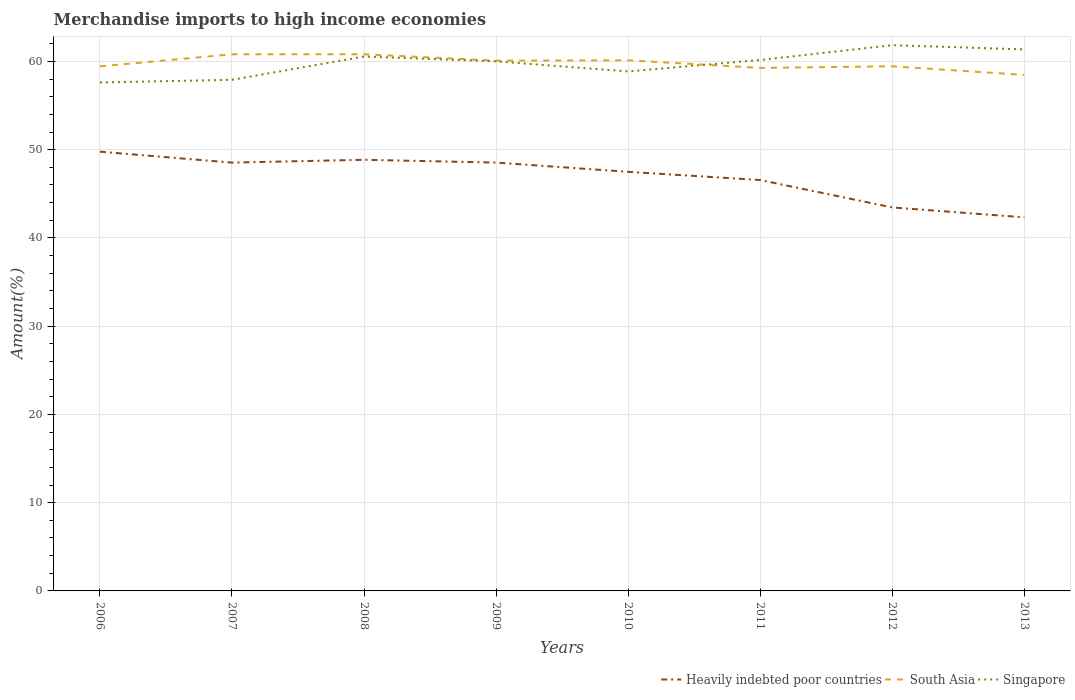Is the number of lines equal to the number of legend labels?
Your response must be concise. Yes. Across all years, what is the maximum percentage of amount earned from merchandise imports in Heavily indebted poor countries?
Your answer should be very brief. 42.33. What is the total percentage of amount earned from merchandise imports in Heavily indebted poor countries in the graph?
Give a very brief answer. -0.32. What is the difference between the highest and the second highest percentage of amount earned from merchandise imports in Heavily indebted poor countries?
Provide a succinct answer. 7.44. What is the difference between the highest and the lowest percentage of amount earned from merchandise imports in Singapore?
Offer a very short reply. 5. How many lines are there?
Your response must be concise. 3. What is the difference between two consecutive major ticks on the Y-axis?
Your response must be concise. 10. Does the graph contain any zero values?
Ensure brevity in your answer.  No. Does the graph contain grids?
Give a very brief answer. Yes. Where does the legend appear in the graph?
Provide a succinct answer. Bottom right. What is the title of the graph?
Offer a terse response. Merchandise imports to high income economies. What is the label or title of the Y-axis?
Provide a succinct answer. Amount(%). What is the Amount(%) of Heavily indebted poor countries in 2006?
Offer a terse response. 49.77. What is the Amount(%) of South Asia in 2006?
Make the answer very short. 59.44. What is the Amount(%) of Singapore in 2006?
Your response must be concise. 57.61. What is the Amount(%) of Heavily indebted poor countries in 2007?
Provide a short and direct response. 48.53. What is the Amount(%) of South Asia in 2007?
Offer a terse response. 60.81. What is the Amount(%) in Singapore in 2007?
Make the answer very short. 57.92. What is the Amount(%) in Heavily indebted poor countries in 2008?
Ensure brevity in your answer.  48.85. What is the Amount(%) in South Asia in 2008?
Offer a terse response. 60.81. What is the Amount(%) in Singapore in 2008?
Your answer should be compact. 60.55. What is the Amount(%) of Heavily indebted poor countries in 2009?
Offer a very short reply. 48.54. What is the Amount(%) of South Asia in 2009?
Make the answer very short. 60.08. What is the Amount(%) in Singapore in 2009?
Ensure brevity in your answer.  60. What is the Amount(%) of Heavily indebted poor countries in 2010?
Keep it short and to the point. 47.49. What is the Amount(%) in South Asia in 2010?
Offer a terse response. 60.13. What is the Amount(%) in Singapore in 2010?
Ensure brevity in your answer.  58.87. What is the Amount(%) of Heavily indebted poor countries in 2011?
Your response must be concise. 46.56. What is the Amount(%) of South Asia in 2011?
Give a very brief answer. 59.26. What is the Amount(%) in Singapore in 2011?
Your answer should be compact. 60.16. What is the Amount(%) of Heavily indebted poor countries in 2012?
Give a very brief answer. 43.45. What is the Amount(%) of South Asia in 2012?
Your answer should be very brief. 59.45. What is the Amount(%) in Singapore in 2012?
Give a very brief answer. 61.84. What is the Amount(%) in Heavily indebted poor countries in 2013?
Offer a very short reply. 42.33. What is the Amount(%) in South Asia in 2013?
Provide a succinct answer. 58.47. What is the Amount(%) of Singapore in 2013?
Keep it short and to the point. 61.36. Across all years, what is the maximum Amount(%) of Heavily indebted poor countries?
Your answer should be very brief. 49.77. Across all years, what is the maximum Amount(%) of South Asia?
Offer a very short reply. 60.81. Across all years, what is the maximum Amount(%) in Singapore?
Your answer should be compact. 61.84. Across all years, what is the minimum Amount(%) in Heavily indebted poor countries?
Provide a succinct answer. 42.33. Across all years, what is the minimum Amount(%) of South Asia?
Ensure brevity in your answer.  58.47. Across all years, what is the minimum Amount(%) in Singapore?
Offer a very short reply. 57.61. What is the total Amount(%) in Heavily indebted poor countries in the graph?
Your answer should be very brief. 375.53. What is the total Amount(%) in South Asia in the graph?
Your answer should be compact. 478.44. What is the total Amount(%) in Singapore in the graph?
Offer a very short reply. 478.32. What is the difference between the Amount(%) in Heavily indebted poor countries in 2006 and that in 2007?
Your answer should be very brief. 1.24. What is the difference between the Amount(%) in South Asia in 2006 and that in 2007?
Give a very brief answer. -1.37. What is the difference between the Amount(%) in Singapore in 2006 and that in 2007?
Give a very brief answer. -0.3. What is the difference between the Amount(%) of Heavily indebted poor countries in 2006 and that in 2008?
Your answer should be very brief. 0.92. What is the difference between the Amount(%) of South Asia in 2006 and that in 2008?
Make the answer very short. -1.37. What is the difference between the Amount(%) of Singapore in 2006 and that in 2008?
Keep it short and to the point. -2.94. What is the difference between the Amount(%) in Heavily indebted poor countries in 2006 and that in 2009?
Keep it short and to the point. 1.24. What is the difference between the Amount(%) in South Asia in 2006 and that in 2009?
Provide a succinct answer. -0.64. What is the difference between the Amount(%) of Singapore in 2006 and that in 2009?
Your answer should be compact. -2.39. What is the difference between the Amount(%) in Heavily indebted poor countries in 2006 and that in 2010?
Keep it short and to the point. 2.28. What is the difference between the Amount(%) of South Asia in 2006 and that in 2010?
Provide a short and direct response. -0.69. What is the difference between the Amount(%) in Singapore in 2006 and that in 2010?
Your answer should be compact. -1.25. What is the difference between the Amount(%) of Heavily indebted poor countries in 2006 and that in 2011?
Give a very brief answer. 3.21. What is the difference between the Amount(%) in South Asia in 2006 and that in 2011?
Your answer should be very brief. 0.18. What is the difference between the Amount(%) in Singapore in 2006 and that in 2011?
Provide a short and direct response. -2.55. What is the difference between the Amount(%) in Heavily indebted poor countries in 2006 and that in 2012?
Your answer should be compact. 6.32. What is the difference between the Amount(%) in South Asia in 2006 and that in 2012?
Provide a short and direct response. -0.01. What is the difference between the Amount(%) of Singapore in 2006 and that in 2012?
Your response must be concise. -4.23. What is the difference between the Amount(%) in Heavily indebted poor countries in 2006 and that in 2013?
Make the answer very short. 7.44. What is the difference between the Amount(%) in South Asia in 2006 and that in 2013?
Give a very brief answer. 0.97. What is the difference between the Amount(%) in Singapore in 2006 and that in 2013?
Offer a very short reply. -3.75. What is the difference between the Amount(%) of Heavily indebted poor countries in 2007 and that in 2008?
Ensure brevity in your answer.  -0.32. What is the difference between the Amount(%) in South Asia in 2007 and that in 2008?
Offer a terse response. -0. What is the difference between the Amount(%) of Singapore in 2007 and that in 2008?
Offer a very short reply. -2.64. What is the difference between the Amount(%) in Heavily indebted poor countries in 2007 and that in 2009?
Provide a short and direct response. -0. What is the difference between the Amount(%) of South Asia in 2007 and that in 2009?
Your answer should be very brief. 0.72. What is the difference between the Amount(%) of Singapore in 2007 and that in 2009?
Ensure brevity in your answer.  -2.09. What is the difference between the Amount(%) of Heavily indebted poor countries in 2007 and that in 2010?
Keep it short and to the point. 1.04. What is the difference between the Amount(%) of South Asia in 2007 and that in 2010?
Make the answer very short. 0.68. What is the difference between the Amount(%) in Singapore in 2007 and that in 2010?
Your response must be concise. -0.95. What is the difference between the Amount(%) of Heavily indebted poor countries in 2007 and that in 2011?
Keep it short and to the point. 1.98. What is the difference between the Amount(%) in South Asia in 2007 and that in 2011?
Your answer should be compact. 1.55. What is the difference between the Amount(%) in Singapore in 2007 and that in 2011?
Your response must be concise. -2.25. What is the difference between the Amount(%) in Heavily indebted poor countries in 2007 and that in 2012?
Provide a short and direct response. 5.08. What is the difference between the Amount(%) of South Asia in 2007 and that in 2012?
Your answer should be compact. 1.36. What is the difference between the Amount(%) in Singapore in 2007 and that in 2012?
Your answer should be very brief. -3.92. What is the difference between the Amount(%) in Heavily indebted poor countries in 2007 and that in 2013?
Provide a short and direct response. 6.2. What is the difference between the Amount(%) in South Asia in 2007 and that in 2013?
Offer a very short reply. 2.34. What is the difference between the Amount(%) in Singapore in 2007 and that in 2013?
Provide a short and direct response. -3.44. What is the difference between the Amount(%) of Heavily indebted poor countries in 2008 and that in 2009?
Provide a succinct answer. 0.32. What is the difference between the Amount(%) of South Asia in 2008 and that in 2009?
Provide a succinct answer. 0.73. What is the difference between the Amount(%) in Singapore in 2008 and that in 2009?
Give a very brief answer. 0.55. What is the difference between the Amount(%) of Heavily indebted poor countries in 2008 and that in 2010?
Your answer should be compact. 1.36. What is the difference between the Amount(%) in South Asia in 2008 and that in 2010?
Offer a terse response. 0.68. What is the difference between the Amount(%) of Singapore in 2008 and that in 2010?
Keep it short and to the point. 1.69. What is the difference between the Amount(%) in Heavily indebted poor countries in 2008 and that in 2011?
Ensure brevity in your answer.  2.3. What is the difference between the Amount(%) of South Asia in 2008 and that in 2011?
Offer a terse response. 1.55. What is the difference between the Amount(%) in Singapore in 2008 and that in 2011?
Give a very brief answer. 0.39. What is the difference between the Amount(%) in Heavily indebted poor countries in 2008 and that in 2012?
Make the answer very short. 5.4. What is the difference between the Amount(%) of South Asia in 2008 and that in 2012?
Provide a short and direct response. 1.36. What is the difference between the Amount(%) of Singapore in 2008 and that in 2012?
Give a very brief answer. -1.29. What is the difference between the Amount(%) in Heavily indebted poor countries in 2008 and that in 2013?
Provide a succinct answer. 6.52. What is the difference between the Amount(%) in South Asia in 2008 and that in 2013?
Keep it short and to the point. 2.34. What is the difference between the Amount(%) of Singapore in 2008 and that in 2013?
Make the answer very short. -0.81. What is the difference between the Amount(%) in Heavily indebted poor countries in 2009 and that in 2010?
Keep it short and to the point. 1.05. What is the difference between the Amount(%) in South Asia in 2009 and that in 2010?
Keep it short and to the point. -0.04. What is the difference between the Amount(%) in Singapore in 2009 and that in 2010?
Your response must be concise. 1.14. What is the difference between the Amount(%) in Heavily indebted poor countries in 2009 and that in 2011?
Your answer should be compact. 1.98. What is the difference between the Amount(%) of South Asia in 2009 and that in 2011?
Ensure brevity in your answer.  0.82. What is the difference between the Amount(%) in Singapore in 2009 and that in 2011?
Provide a short and direct response. -0.16. What is the difference between the Amount(%) in Heavily indebted poor countries in 2009 and that in 2012?
Ensure brevity in your answer.  5.08. What is the difference between the Amount(%) of South Asia in 2009 and that in 2012?
Provide a succinct answer. 0.63. What is the difference between the Amount(%) in Singapore in 2009 and that in 2012?
Your answer should be compact. -1.84. What is the difference between the Amount(%) in Heavily indebted poor countries in 2009 and that in 2013?
Ensure brevity in your answer.  6.2. What is the difference between the Amount(%) of South Asia in 2009 and that in 2013?
Make the answer very short. 1.62. What is the difference between the Amount(%) in Singapore in 2009 and that in 2013?
Provide a succinct answer. -1.36. What is the difference between the Amount(%) of Heavily indebted poor countries in 2010 and that in 2011?
Your response must be concise. 0.93. What is the difference between the Amount(%) in South Asia in 2010 and that in 2011?
Provide a succinct answer. 0.87. What is the difference between the Amount(%) of Singapore in 2010 and that in 2011?
Offer a terse response. -1.3. What is the difference between the Amount(%) of Heavily indebted poor countries in 2010 and that in 2012?
Your response must be concise. 4.03. What is the difference between the Amount(%) in South Asia in 2010 and that in 2012?
Offer a terse response. 0.68. What is the difference between the Amount(%) of Singapore in 2010 and that in 2012?
Provide a succinct answer. -2.97. What is the difference between the Amount(%) in Heavily indebted poor countries in 2010 and that in 2013?
Offer a terse response. 5.16. What is the difference between the Amount(%) of South Asia in 2010 and that in 2013?
Provide a succinct answer. 1.66. What is the difference between the Amount(%) of Singapore in 2010 and that in 2013?
Offer a very short reply. -2.49. What is the difference between the Amount(%) in Heavily indebted poor countries in 2011 and that in 2012?
Provide a succinct answer. 3.1. What is the difference between the Amount(%) in South Asia in 2011 and that in 2012?
Your answer should be very brief. -0.19. What is the difference between the Amount(%) in Singapore in 2011 and that in 2012?
Give a very brief answer. -1.68. What is the difference between the Amount(%) in Heavily indebted poor countries in 2011 and that in 2013?
Offer a very short reply. 4.23. What is the difference between the Amount(%) in South Asia in 2011 and that in 2013?
Make the answer very short. 0.79. What is the difference between the Amount(%) in Singapore in 2011 and that in 2013?
Offer a very short reply. -1.2. What is the difference between the Amount(%) in Heavily indebted poor countries in 2012 and that in 2013?
Offer a very short reply. 1.12. What is the difference between the Amount(%) of South Asia in 2012 and that in 2013?
Give a very brief answer. 0.98. What is the difference between the Amount(%) in Singapore in 2012 and that in 2013?
Ensure brevity in your answer.  0.48. What is the difference between the Amount(%) of Heavily indebted poor countries in 2006 and the Amount(%) of South Asia in 2007?
Your answer should be compact. -11.03. What is the difference between the Amount(%) in Heavily indebted poor countries in 2006 and the Amount(%) in Singapore in 2007?
Your answer should be compact. -8.15. What is the difference between the Amount(%) of South Asia in 2006 and the Amount(%) of Singapore in 2007?
Offer a very short reply. 1.52. What is the difference between the Amount(%) of Heavily indebted poor countries in 2006 and the Amount(%) of South Asia in 2008?
Keep it short and to the point. -11.04. What is the difference between the Amount(%) in Heavily indebted poor countries in 2006 and the Amount(%) in Singapore in 2008?
Your answer should be compact. -10.78. What is the difference between the Amount(%) of South Asia in 2006 and the Amount(%) of Singapore in 2008?
Your answer should be compact. -1.11. What is the difference between the Amount(%) of Heavily indebted poor countries in 2006 and the Amount(%) of South Asia in 2009?
Offer a very short reply. -10.31. What is the difference between the Amount(%) of Heavily indebted poor countries in 2006 and the Amount(%) of Singapore in 2009?
Provide a short and direct response. -10.23. What is the difference between the Amount(%) in South Asia in 2006 and the Amount(%) in Singapore in 2009?
Offer a terse response. -0.56. What is the difference between the Amount(%) of Heavily indebted poor countries in 2006 and the Amount(%) of South Asia in 2010?
Your answer should be compact. -10.36. What is the difference between the Amount(%) of Heavily indebted poor countries in 2006 and the Amount(%) of Singapore in 2010?
Your response must be concise. -9.09. What is the difference between the Amount(%) in South Asia in 2006 and the Amount(%) in Singapore in 2010?
Offer a terse response. 0.57. What is the difference between the Amount(%) of Heavily indebted poor countries in 2006 and the Amount(%) of South Asia in 2011?
Keep it short and to the point. -9.49. What is the difference between the Amount(%) of Heavily indebted poor countries in 2006 and the Amount(%) of Singapore in 2011?
Offer a terse response. -10.39. What is the difference between the Amount(%) in South Asia in 2006 and the Amount(%) in Singapore in 2011?
Give a very brief answer. -0.72. What is the difference between the Amount(%) of Heavily indebted poor countries in 2006 and the Amount(%) of South Asia in 2012?
Your answer should be compact. -9.68. What is the difference between the Amount(%) of Heavily indebted poor countries in 2006 and the Amount(%) of Singapore in 2012?
Give a very brief answer. -12.07. What is the difference between the Amount(%) in South Asia in 2006 and the Amount(%) in Singapore in 2012?
Make the answer very short. -2.4. What is the difference between the Amount(%) of Heavily indebted poor countries in 2006 and the Amount(%) of South Asia in 2013?
Provide a succinct answer. -8.7. What is the difference between the Amount(%) of Heavily indebted poor countries in 2006 and the Amount(%) of Singapore in 2013?
Make the answer very short. -11.59. What is the difference between the Amount(%) in South Asia in 2006 and the Amount(%) in Singapore in 2013?
Provide a succinct answer. -1.92. What is the difference between the Amount(%) of Heavily indebted poor countries in 2007 and the Amount(%) of South Asia in 2008?
Make the answer very short. -12.28. What is the difference between the Amount(%) in Heavily indebted poor countries in 2007 and the Amount(%) in Singapore in 2008?
Offer a terse response. -12.02. What is the difference between the Amount(%) in South Asia in 2007 and the Amount(%) in Singapore in 2008?
Your answer should be very brief. 0.25. What is the difference between the Amount(%) in Heavily indebted poor countries in 2007 and the Amount(%) in South Asia in 2009?
Provide a short and direct response. -11.55. What is the difference between the Amount(%) in Heavily indebted poor countries in 2007 and the Amount(%) in Singapore in 2009?
Provide a short and direct response. -11.47. What is the difference between the Amount(%) in South Asia in 2007 and the Amount(%) in Singapore in 2009?
Make the answer very short. 0.8. What is the difference between the Amount(%) of Heavily indebted poor countries in 2007 and the Amount(%) of South Asia in 2010?
Your answer should be compact. -11.59. What is the difference between the Amount(%) of Heavily indebted poor countries in 2007 and the Amount(%) of Singapore in 2010?
Provide a succinct answer. -10.33. What is the difference between the Amount(%) in South Asia in 2007 and the Amount(%) in Singapore in 2010?
Offer a terse response. 1.94. What is the difference between the Amount(%) in Heavily indebted poor countries in 2007 and the Amount(%) in South Asia in 2011?
Your answer should be compact. -10.73. What is the difference between the Amount(%) of Heavily indebted poor countries in 2007 and the Amount(%) of Singapore in 2011?
Make the answer very short. -11.63. What is the difference between the Amount(%) of South Asia in 2007 and the Amount(%) of Singapore in 2011?
Offer a very short reply. 0.64. What is the difference between the Amount(%) in Heavily indebted poor countries in 2007 and the Amount(%) in South Asia in 2012?
Your response must be concise. -10.92. What is the difference between the Amount(%) of Heavily indebted poor countries in 2007 and the Amount(%) of Singapore in 2012?
Your answer should be very brief. -13.31. What is the difference between the Amount(%) of South Asia in 2007 and the Amount(%) of Singapore in 2012?
Offer a very short reply. -1.03. What is the difference between the Amount(%) of Heavily indebted poor countries in 2007 and the Amount(%) of South Asia in 2013?
Your response must be concise. -9.93. What is the difference between the Amount(%) in Heavily indebted poor countries in 2007 and the Amount(%) in Singapore in 2013?
Your answer should be very brief. -12.83. What is the difference between the Amount(%) of South Asia in 2007 and the Amount(%) of Singapore in 2013?
Offer a terse response. -0.56. What is the difference between the Amount(%) in Heavily indebted poor countries in 2008 and the Amount(%) in South Asia in 2009?
Offer a terse response. -11.23. What is the difference between the Amount(%) in Heavily indebted poor countries in 2008 and the Amount(%) in Singapore in 2009?
Provide a succinct answer. -11.15. What is the difference between the Amount(%) of South Asia in 2008 and the Amount(%) of Singapore in 2009?
Your response must be concise. 0.81. What is the difference between the Amount(%) of Heavily indebted poor countries in 2008 and the Amount(%) of South Asia in 2010?
Provide a short and direct response. -11.27. What is the difference between the Amount(%) in Heavily indebted poor countries in 2008 and the Amount(%) in Singapore in 2010?
Provide a short and direct response. -10.01. What is the difference between the Amount(%) of South Asia in 2008 and the Amount(%) of Singapore in 2010?
Offer a terse response. 1.94. What is the difference between the Amount(%) in Heavily indebted poor countries in 2008 and the Amount(%) in South Asia in 2011?
Make the answer very short. -10.41. What is the difference between the Amount(%) in Heavily indebted poor countries in 2008 and the Amount(%) in Singapore in 2011?
Keep it short and to the point. -11.31. What is the difference between the Amount(%) in South Asia in 2008 and the Amount(%) in Singapore in 2011?
Offer a very short reply. 0.65. What is the difference between the Amount(%) of Heavily indebted poor countries in 2008 and the Amount(%) of South Asia in 2012?
Ensure brevity in your answer.  -10.6. What is the difference between the Amount(%) in Heavily indebted poor countries in 2008 and the Amount(%) in Singapore in 2012?
Your answer should be very brief. -12.99. What is the difference between the Amount(%) of South Asia in 2008 and the Amount(%) of Singapore in 2012?
Ensure brevity in your answer.  -1.03. What is the difference between the Amount(%) in Heavily indebted poor countries in 2008 and the Amount(%) in South Asia in 2013?
Offer a terse response. -9.61. What is the difference between the Amount(%) in Heavily indebted poor countries in 2008 and the Amount(%) in Singapore in 2013?
Provide a short and direct response. -12.51. What is the difference between the Amount(%) of South Asia in 2008 and the Amount(%) of Singapore in 2013?
Ensure brevity in your answer.  -0.55. What is the difference between the Amount(%) in Heavily indebted poor countries in 2009 and the Amount(%) in South Asia in 2010?
Provide a short and direct response. -11.59. What is the difference between the Amount(%) of Heavily indebted poor countries in 2009 and the Amount(%) of Singapore in 2010?
Your answer should be compact. -10.33. What is the difference between the Amount(%) of South Asia in 2009 and the Amount(%) of Singapore in 2010?
Give a very brief answer. 1.22. What is the difference between the Amount(%) of Heavily indebted poor countries in 2009 and the Amount(%) of South Asia in 2011?
Offer a terse response. -10.72. What is the difference between the Amount(%) in Heavily indebted poor countries in 2009 and the Amount(%) in Singapore in 2011?
Offer a terse response. -11.63. What is the difference between the Amount(%) of South Asia in 2009 and the Amount(%) of Singapore in 2011?
Provide a succinct answer. -0.08. What is the difference between the Amount(%) of Heavily indebted poor countries in 2009 and the Amount(%) of South Asia in 2012?
Ensure brevity in your answer.  -10.91. What is the difference between the Amount(%) of Heavily indebted poor countries in 2009 and the Amount(%) of Singapore in 2012?
Provide a succinct answer. -13.3. What is the difference between the Amount(%) in South Asia in 2009 and the Amount(%) in Singapore in 2012?
Keep it short and to the point. -1.76. What is the difference between the Amount(%) in Heavily indebted poor countries in 2009 and the Amount(%) in South Asia in 2013?
Give a very brief answer. -9.93. What is the difference between the Amount(%) of Heavily indebted poor countries in 2009 and the Amount(%) of Singapore in 2013?
Make the answer very short. -12.83. What is the difference between the Amount(%) in South Asia in 2009 and the Amount(%) in Singapore in 2013?
Give a very brief answer. -1.28. What is the difference between the Amount(%) of Heavily indebted poor countries in 2010 and the Amount(%) of South Asia in 2011?
Give a very brief answer. -11.77. What is the difference between the Amount(%) of Heavily indebted poor countries in 2010 and the Amount(%) of Singapore in 2011?
Provide a short and direct response. -12.67. What is the difference between the Amount(%) of South Asia in 2010 and the Amount(%) of Singapore in 2011?
Keep it short and to the point. -0.04. What is the difference between the Amount(%) in Heavily indebted poor countries in 2010 and the Amount(%) in South Asia in 2012?
Give a very brief answer. -11.96. What is the difference between the Amount(%) of Heavily indebted poor countries in 2010 and the Amount(%) of Singapore in 2012?
Give a very brief answer. -14.35. What is the difference between the Amount(%) in South Asia in 2010 and the Amount(%) in Singapore in 2012?
Provide a short and direct response. -1.71. What is the difference between the Amount(%) in Heavily indebted poor countries in 2010 and the Amount(%) in South Asia in 2013?
Ensure brevity in your answer.  -10.98. What is the difference between the Amount(%) of Heavily indebted poor countries in 2010 and the Amount(%) of Singapore in 2013?
Provide a succinct answer. -13.87. What is the difference between the Amount(%) of South Asia in 2010 and the Amount(%) of Singapore in 2013?
Make the answer very short. -1.23. What is the difference between the Amount(%) in Heavily indebted poor countries in 2011 and the Amount(%) in South Asia in 2012?
Provide a short and direct response. -12.89. What is the difference between the Amount(%) in Heavily indebted poor countries in 2011 and the Amount(%) in Singapore in 2012?
Ensure brevity in your answer.  -15.28. What is the difference between the Amount(%) of South Asia in 2011 and the Amount(%) of Singapore in 2012?
Offer a very short reply. -2.58. What is the difference between the Amount(%) in Heavily indebted poor countries in 2011 and the Amount(%) in South Asia in 2013?
Provide a succinct answer. -11.91. What is the difference between the Amount(%) in Heavily indebted poor countries in 2011 and the Amount(%) in Singapore in 2013?
Offer a very short reply. -14.8. What is the difference between the Amount(%) of South Asia in 2011 and the Amount(%) of Singapore in 2013?
Ensure brevity in your answer.  -2.1. What is the difference between the Amount(%) in Heavily indebted poor countries in 2012 and the Amount(%) in South Asia in 2013?
Ensure brevity in your answer.  -15.01. What is the difference between the Amount(%) of Heavily indebted poor countries in 2012 and the Amount(%) of Singapore in 2013?
Offer a very short reply. -17.91. What is the difference between the Amount(%) in South Asia in 2012 and the Amount(%) in Singapore in 2013?
Your answer should be compact. -1.91. What is the average Amount(%) of Heavily indebted poor countries per year?
Your answer should be very brief. 46.94. What is the average Amount(%) of South Asia per year?
Make the answer very short. 59.81. What is the average Amount(%) in Singapore per year?
Ensure brevity in your answer.  59.79. In the year 2006, what is the difference between the Amount(%) in Heavily indebted poor countries and Amount(%) in South Asia?
Your answer should be compact. -9.67. In the year 2006, what is the difference between the Amount(%) of Heavily indebted poor countries and Amount(%) of Singapore?
Offer a terse response. -7.84. In the year 2006, what is the difference between the Amount(%) of South Asia and Amount(%) of Singapore?
Give a very brief answer. 1.83. In the year 2007, what is the difference between the Amount(%) of Heavily indebted poor countries and Amount(%) of South Asia?
Provide a short and direct response. -12.27. In the year 2007, what is the difference between the Amount(%) of Heavily indebted poor countries and Amount(%) of Singapore?
Offer a terse response. -9.38. In the year 2007, what is the difference between the Amount(%) in South Asia and Amount(%) in Singapore?
Provide a short and direct response. 2.89. In the year 2008, what is the difference between the Amount(%) of Heavily indebted poor countries and Amount(%) of South Asia?
Make the answer very short. -11.96. In the year 2008, what is the difference between the Amount(%) in Heavily indebted poor countries and Amount(%) in Singapore?
Give a very brief answer. -11.7. In the year 2008, what is the difference between the Amount(%) in South Asia and Amount(%) in Singapore?
Make the answer very short. 0.26. In the year 2009, what is the difference between the Amount(%) in Heavily indebted poor countries and Amount(%) in South Asia?
Make the answer very short. -11.55. In the year 2009, what is the difference between the Amount(%) in Heavily indebted poor countries and Amount(%) in Singapore?
Offer a terse response. -11.47. In the year 2009, what is the difference between the Amount(%) of South Asia and Amount(%) of Singapore?
Provide a short and direct response. 0.08. In the year 2010, what is the difference between the Amount(%) of Heavily indebted poor countries and Amount(%) of South Asia?
Make the answer very short. -12.64. In the year 2010, what is the difference between the Amount(%) of Heavily indebted poor countries and Amount(%) of Singapore?
Provide a short and direct response. -11.38. In the year 2010, what is the difference between the Amount(%) in South Asia and Amount(%) in Singapore?
Offer a terse response. 1.26. In the year 2011, what is the difference between the Amount(%) in Heavily indebted poor countries and Amount(%) in South Asia?
Make the answer very short. -12.7. In the year 2011, what is the difference between the Amount(%) of Heavily indebted poor countries and Amount(%) of Singapore?
Your response must be concise. -13.61. In the year 2011, what is the difference between the Amount(%) of South Asia and Amount(%) of Singapore?
Your answer should be very brief. -0.9. In the year 2012, what is the difference between the Amount(%) in Heavily indebted poor countries and Amount(%) in South Asia?
Keep it short and to the point. -15.99. In the year 2012, what is the difference between the Amount(%) of Heavily indebted poor countries and Amount(%) of Singapore?
Your answer should be very brief. -18.38. In the year 2012, what is the difference between the Amount(%) of South Asia and Amount(%) of Singapore?
Your response must be concise. -2.39. In the year 2013, what is the difference between the Amount(%) in Heavily indebted poor countries and Amount(%) in South Asia?
Provide a short and direct response. -16.14. In the year 2013, what is the difference between the Amount(%) in Heavily indebted poor countries and Amount(%) in Singapore?
Your response must be concise. -19.03. In the year 2013, what is the difference between the Amount(%) of South Asia and Amount(%) of Singapore?
Make the answer very short. -2.89. What is the ratio of the Amount(%) of Heavily indebted poor countries in 2006 to that in 2007?
Ensure brevity in your answer.  1.03. What is the ratio of the Amount(%) in South Asia in 2006 to that in 2007?
Provide a succinct answer. 0.98. What is the ratio of the Amount(%) in Heavily indebted poor countries in 2006 to that in 2008?
Give a very brief answer. 1.02. What is the ratio of the Amount(%) in South Asia in 2006 to that in 2008?
Offer a terse response. 0.98. What is the ratio of the Amount(%) of Singapore in 2006 to that in 2008?
Provide a succinct answer. 0.95. What is the ratio of the Amount(%) in Heavily indebted poor countries in 2006 to that in 2009?
Provide a short and direct response. 1.03. What is the ratio of the Amount(%) of South Asia in 2006 to that in 2009?
Your answer should be very brief. 0.99. What is the ratio of the Amount(%) of Singapore in 2006 to that in 2009?
Offer a terse response. 0.96. What is the ratio of the Amount(%) in Heavily indebted poor countries in 2006 to that in 2010?
Provide a short and direct response. 1.05. What is the ratio of the Amount(%) of South Asia in 2006 to that in 2010?
Keep it short and to the point. 0.99. What is the ratio of the Amount(%) in Singapore in 2006 to that in 2010?
Make the answer very short. 0.98. What is the ratio of the Amount(%) in Heavily indebted poor countries in 2006 to that in 2011?
Ensure brevity in your answer.  1.07. What is the ratio of the Amount(%) of Singapore in 2006 to that in 2011?
Your response must be concise. 0.96. What is the ratio of the Amount(%) in Heavily indebted poor countries in 2006 to that in 2012?
Give a very brief answer. 1.15. What is the ratio of the Amount(%) of South Asia in 2006 to that in 2012?
Offer a terse response. 1. What is the ratio of the Amount(%) in Singapore in 2006 to that in 2012?
Provide a short and direct response. 0.93. What is the ratio of the Amount(%) in Heavily indebted poor countries in 2006 to that in 2013?
Keep it short and to the point. 1.18. What is the ratio of the Amount(%) of South Asia in 2006 to that in 2013?
Offer a terse response. 1.02. What is the ratio of the Amount(%) in Singapore in 2006 to that in 2013?
Make the answer very short. 0.94. What is the ratio of the Amount(%) in Singapore in 2007 to that in 2008?
Your answer should be compact. 0.96. What is the ratio of the Amount(%) in Heavily indebted poor countries in 2007 to that in 2009?
Offer a very short reply. 1. What is the ratio of the Amount(%) in South Asia in 2007 to that in 2009?
Provide a short and direct response. 1.01. What is the ratio of the Amount(%) in Singapore in 2007 to that in 2009?
Offer a terse response. 0.97. What is the ratio of the Amount(%) in Heavily indebted poor countries in 2007 to that in 2010?
Ensure brevity in your answer.  1.02. What is the ratio of the Amount(%) in South Asia in 2007 to that in 2010?
Provide a short and direct response. 1.01. What is the ratio of the Amount(%) in Singapore in 2007 to that in 2010?
Your answer should be compact. 0.98. What is the ratio of the Amount(%) of Heavily indebted poor countries in 2007 to that in 2011?
Your answer should be compact. 1.04. What is the ratio of the Amount(%) of South Asia in 2007 to that in 2011?
Make the answer very short. 1.03. What is the ratio of the Amount(%) in Singapore in 2007 to that in 2011?
Offer a terse response. 0.96. What is the ratio of the Amount(%) of Heavily indebted poor countries in 2007 to that in 2012?
Your answer should be very brief. 1.12. What is the ratio of the Amount(%) in South Asia in 2007 to that in 2012?
Offer a very short reply. 1.02. What is the ratio of the Amount(%) of Singapore in 2007 to that in 2012?
Provide a short and direct response. 0.94. What is the ratio of the Amount(%) in Heavily indebted poor countries in 2007 to that in 2013?
Provide a short and direct response. 1.15. What is the ratio of the Amount(%) in Singapore in 2007 to that in 2013?
Provide a succinct answer. 0.94. What is the ratio of the Amount(%) of Heavily indebted poor countries in 2008 to that in 2009?
Provide a short and direct response. 1.01. What is the ratio of the Amount(%) in South Asia in 2008 to that in 2009?
Provide a short and direct response. 1.01. What is the ratio of the Amount(%) in Singapore in 2008 to that in 2009?
Your response must be concise. 1.01. What is the ratio of the Amount(%) in Heavily indebted poor countries in 2008 to that in 2010?
Offer a terse response. 1.03. What is the ratio of the Amount(%) in South Asia in 2008 to that in 2010?
Offer a terse response. 1.01. What is the ratio of the Amount(%) in Singapore in 2008 to that in 2010?
Offer a terse response. 1.03. What is the ratio of the Amount(%) in Heavily indebted poor countries in 2008 to that in 2011?
Keep it short and to the point. 1.05. What is the ratio of the Amount(%) of South Asia in 2008 to that in 2011?
Your answer should be very brief. 1.03. What is the ratio of the Amount(%) in Heavily indebted poor countries in 2008 to that in 2012?
Offer a very short reply. 1.12. What is the ratio of the Amount(%) in South Asia in 2008 to that in 2012?
Provide a succinct answer. 1.02. What is the ratio of the Amount(%) of Singapore in 2008 to that in 2012?
Ensure brevity in your answer.  0.98. What is the ratio of the Amount(%) in Heavily indebted poor countries in 2008 to that in 2013?
Ensure brevity in your answer.  1.15. What is the ratio of the Amount(%) of South Asia in 2008 to that in 2013?
Provide a succinct answer. 1.04. What is the ratio of the Amount(%) of South Asia in 2009 to that in 2010?
Give a very brief answer. 1. What is the ratio of the Amount(%) of Singapore in 2009 to that in 2010?
Give a very brief answer. 1.02. What is the ratio of the Amount(%) in Heavily indebted poor countries in 2009 to that in 2011?
Your answer should be very brief. 1.04. What is the ratio of the Amount(%) of South Asia in 2009 to that in 2011?
Offer a terse response. 1.01. What is the ratio of the Amount(%) of Singapore in 2009 to that in 2011?
Offer a terse response. 1. What is the ratio of the Amount(%) of Heavily indebted poor countries in 2009 to that in 2012?
Provide a succinct answer. 1.12. What is the ratio of the Amount(%) in South Asia in 2009 to that in 2012?
Provide a short and direct response. 1.01. What is the ratio of the Amount(%) of Singapore in 2009 to that in 2012?
Your answer should be very brief. 0.97. What is the ratio of the Amount(%) in Heavily indebted poor countries in 2009 to that in 2013?
Your response must be concise. 1.15. What is the ratio of the Amount(%) of South Asia in 2009 to that in 2013?
Your response must be concise. 1.03. What is the ratio of the Amount(%) of Singapore in 2009 to that in 2013?
Provide a succinct answer. 0.98. What is the ratio of the Amount(%) of Heavily indebted poor countries in 2010 to that in 2011?
Provide a succinct answer. 1.02. What is the ratio of the Amount(%) of South Asia in 2010 to that in 2011?
Your answer should be very brief. 1.01. What is the ratio of the Amount(%) of Singapore in 2010 to that in 2011?
Your answer should be very brief. 0.98. What is the ratio of the Amount(%) in Heavily indebted poor countries in 2010 to that in 2012?
Keep it short and to the point. 1.09. What is the ratio of the Amount(%) in South Asia in 2010 to that in 2012?
Ensure brevity in your answer.  1.01. What is the ratio of the Amount(%) of Singapore in 2010 to that in 2012?
Ensure brevity in your answer.  0.95. What is the ratio of the Amount(%) of Heavily indebted poor countries in 2010 to that in 2013?
Your answer should be very brief. 1.12. What is the ratio of the Amount(%) in South Asia in 2010 to that in 2013?
Ensure brevity in your answer.  1.03. What is the ratio of the Amount(%) of Singapore in 2010 to that in 2013?
Your answer should be compact. 0.96. What is the ratio of the Amount(%) of Heavily indebted poor countries in 2011 to that in 2012?
Make the answer very short. 1.07. What is the ratio of the Amount(%) in South Asia in 2011 to that in 2012?
Offer a terse response. 1. What is the ratio of the Amount(%) in Singapore in 2011 to that in 2012?
Provide a short and direct response. 0.97. What is the ratio of the Amount(%) of Heavily indebted poor countries in 2011 to that in 2013?
Give a very brief answer. 1.1. What is the ratio of the Amount(%) in South Asia in 2011 to that in 2013?
Provide a succinct answer. 1.01. What is the ratio of the Amount(%) of Singapore in 2011 to that in 2013?
Your answer should be compact. 0.98. What is the ratio of the Amount(%) in Heavily indebted poor countries in 2012 to that in 2013?
Offer a very short reply. 1.03. What is the ratio of the Amount(%) in South Asia in 2012 to that in 2013?
Ensure brevity in your answer.  1.02. What is the difference between the highest and the second highest Amount(%) of Heavily indebted poor countries?
Your response must be concise. 0.92. What is the difference between the highest and the second highest Amount(%) in South Asia?
Offer a terse response. 0. What is the difference between the highest and the second highest Amount(%) in Singapore?
Your answer should be very brief. 0.48. What is the difference between the highest and the lowest Amount(%) of Heavily indebted poor countries?
Your answer should be compact. 7.44. What is the difference between the highest and the lowest Amount(%) of South Asia?
Make the answer very short. 2.34. What is the difference between the highest and the lowest Amount(%) in Singapore?
Provide a short and direct response. 4.23. 